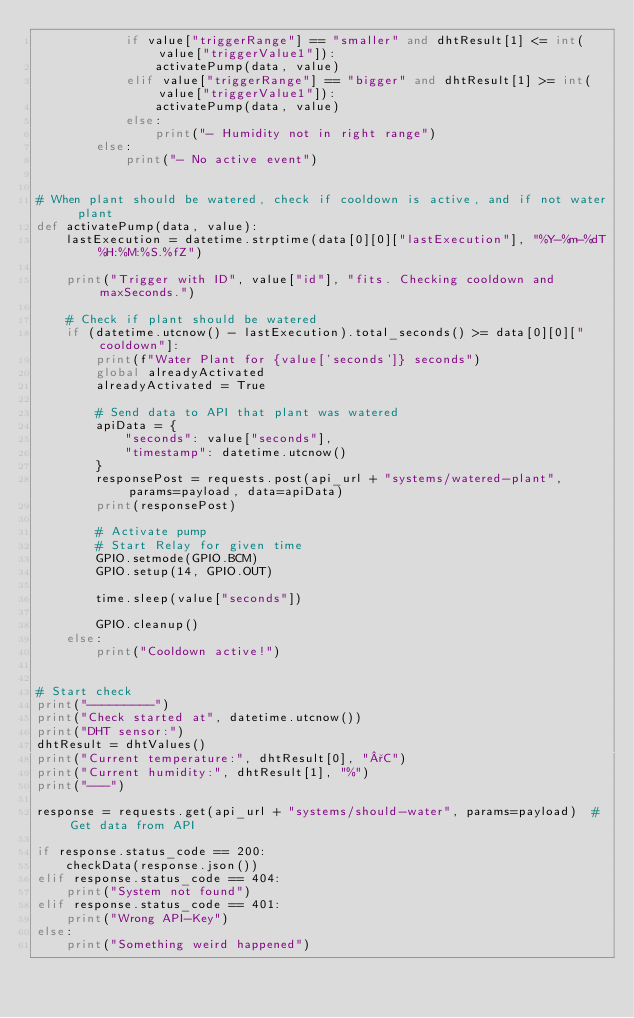Convert code to text. <code><loc_0><loc_0><loc_500><loc_500><_Python_>            if value["triggerRange"] == "smaller" and dhtResult[1] <= int(value["triggerValue1"]):
                activatePump(data, value)
            elif value["triggerRange"] == "bigger" and dhtResult[1] >= int(value["triggerValue1"]):
                activatePump(data, value)
            else:
                print("- Humidity not in right range")
        else:
            print("- No active event")


# When plant should be watered, check if cooldown is active, and if not water plant
def activatePump(data, value):
    lastExecution = datetime.strptime(data[0][0]["lastExecution"], "%Y-%m-%dT%H:%M:%S.%fZ")

    print("Trigger with ID", value["id"], "fits. Checking cooldown and maxSeconds.")

    # Check if plant should be watered
    if (datetime.utcnow() - lastExecution).total_seconds() >= data[0][0]["cooldown"]:
        print(f"Water Plant for {value['seconds']} seconds")
        global alreadyActivated
        alreadyActivated = True

        # Send data to API that plant was watered
        apiData = {
            "seconds": value["seconds"],
            "timestamp": datetime.utcnow()
        }
        responsePost = requests.post(api_url + "systems/watered-plant", params=payload, data=apiData)
        print(responsePost)

        # Activate pump
        # Start Relay for given time
        GPIO.setmode(GPIO.BCM)
        GPIO.setup(14, GPIO.OUT)

        time.sleep(value["seconds"])

        GPIO.cleanup()
    else:
        print("Cooldown active!")


# Start check
print("---------")
print("Check started at", datetime.utcnow())
print("DHT sensor:")
dhtResult = dhtValues()
print("Current temperature:", dhtResult[0], "°C")
print("Current humidity:", dhtResult[1], "%")
print("---")

response = requests.get(api_url + "systems/should-water", params=payload)  # Get data from API

if response.status_code == 200:
    checkData(response.json())
elif response.status_code == 404:
    print("System not found")
elif response.status_code == 401:
    print("Wrong API-Key")
else:
    print("Something weird happened")
</code> 